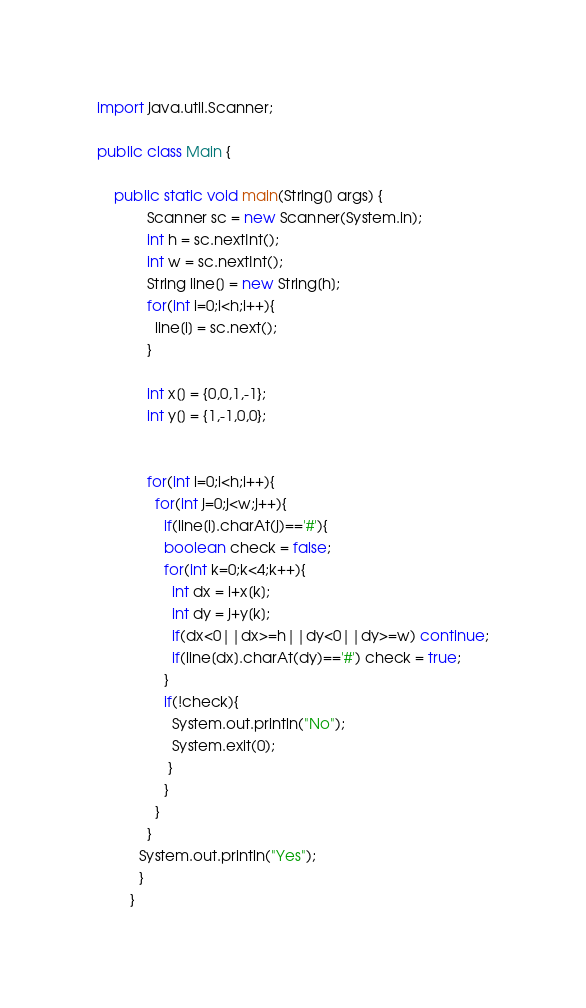<code> <loc_0><loc_0><loc_500><loc_500><_Java_>import java.util.Scanner;

public class Main {

    public static void main(String[] args) {
            Scanner sc = new Scanner(System.in);
            int h = sc.nextInt();
            int w = sc.nextInt();
            String line[] = new String[h];
            for(int i=0;i<h;i++){
              line[i] = sc.next();
            }

            int x[] = {0,0,1,-1};
            int y[] = {1,-1,0,0};

            
            for(int i=0;i<h;i++){
              for(int j=0;j<w;j++){
                if(line[i].charAt(j)=='#'){
                boolean check = false;
                for(int k=0;k<4;k++){
                  int dx = i+x[k];
                  int dy = j+y[k];
                  if(dx<0||dx>=h||dy<0||dy>=w) continue;
                  if(line[dx].charAt(dy)=='#') check = true;
                }
                if(!check){
                  System.out.println("No");
                  System.exit(0);
                 }
                }
              }
            }
          System.out.println("Yes");
          }
        }</code> 